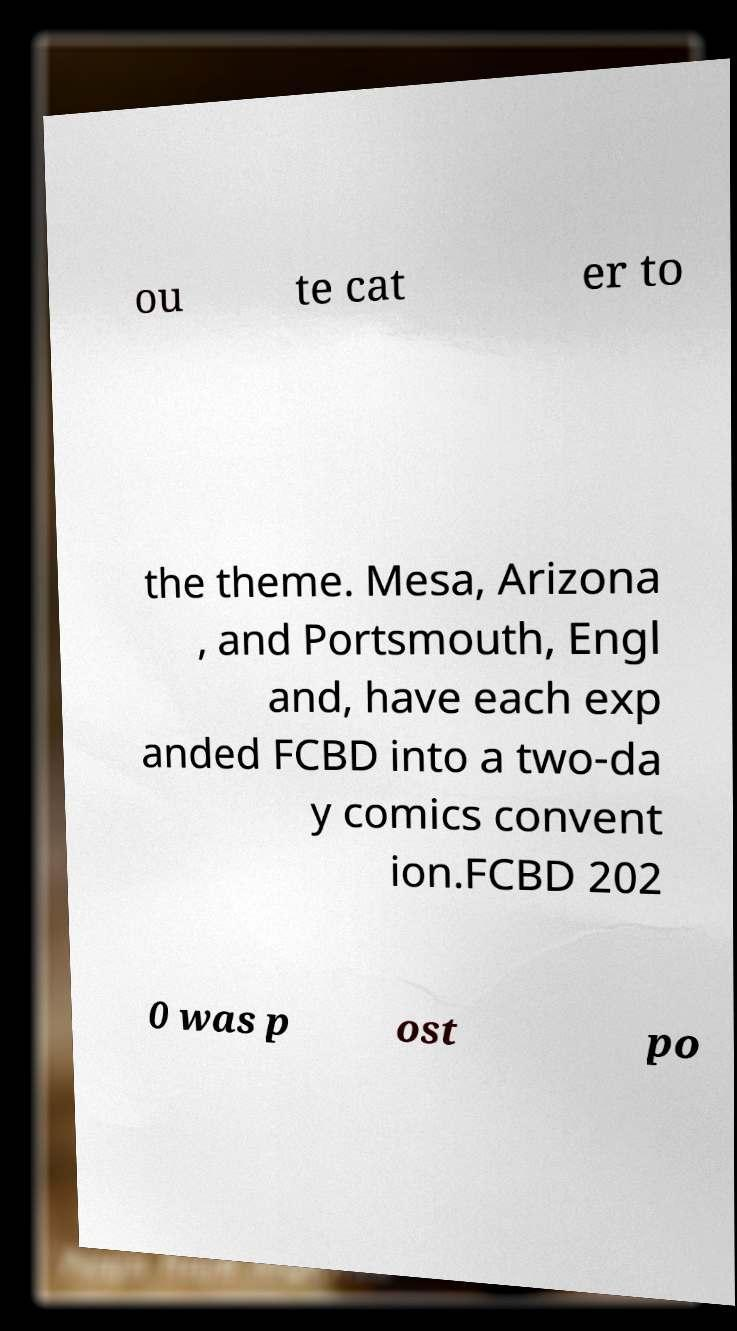Please read and relay the text visible in this image. What does it say? ou te cat er to the theme. Mesa, Arizona , and Portsmouth, Engl and, have each exp anded FCBD into a two-da y comics convent ion.FCBD 202 0 was p ost po 